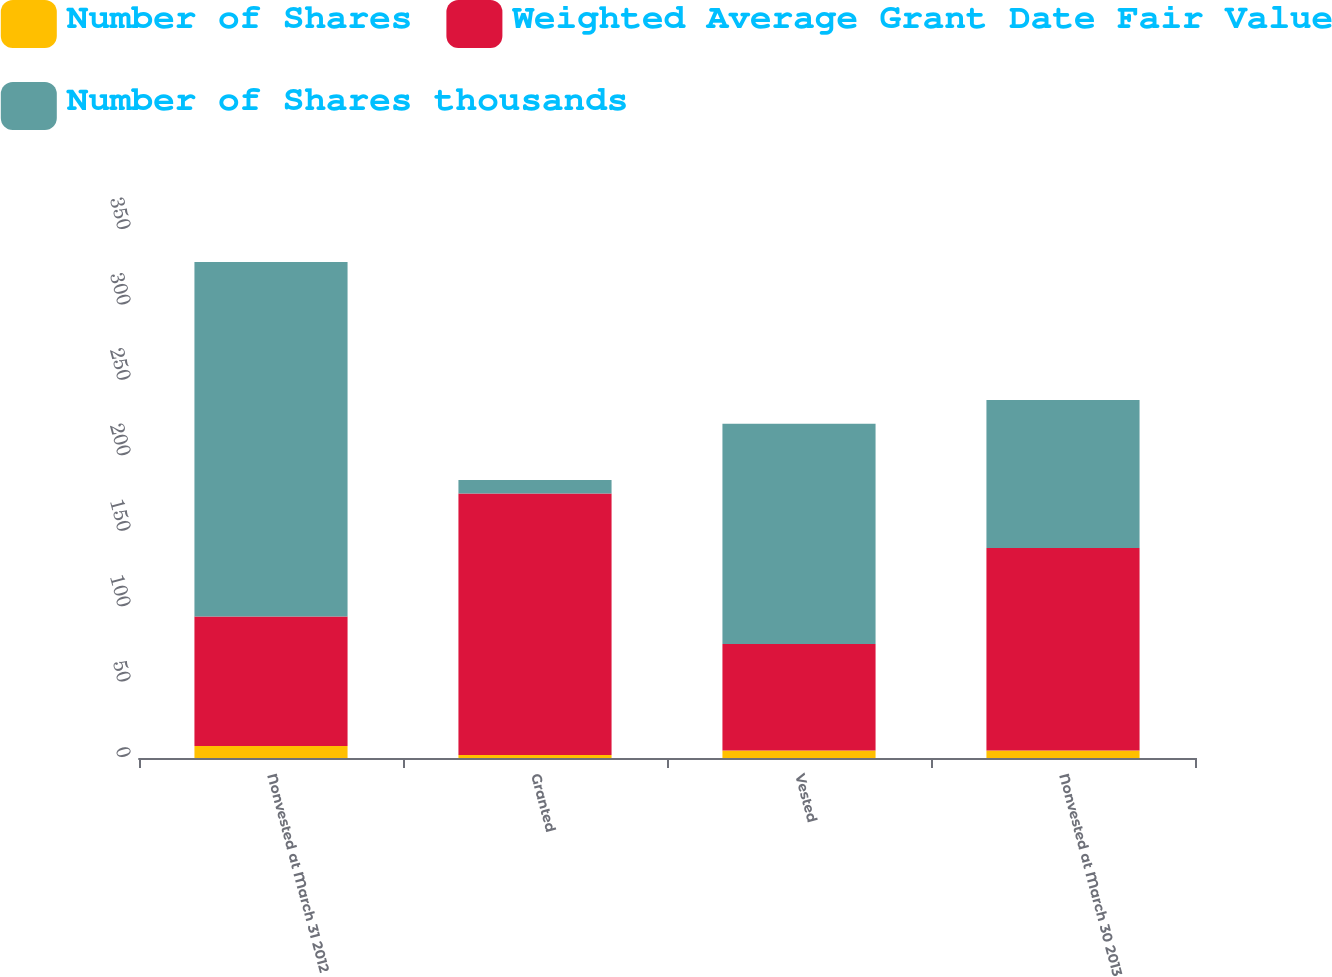Convert chart. <chart><loc_0><loc_0><loc_500><loc_500><stacked_bar_chart><ecel><fcel>Nonvested at March 31 2012<fcel>Granted<fcel>Vested<fcel>Nonvested at March 30 2013<nl><fcel>Number of Shares<fcel>8<fcel>2<fcel>5<fcel>5<nl><fcel>Weighted Average Grant Date Fair Value<fcel>85.87<fcel>173.33<fcel>70.58<fcel>134.28<nl><fcel>Number of Shares thousands<fcel>235<fcel>9<fcel>146<fcel>98<nl></chart> 